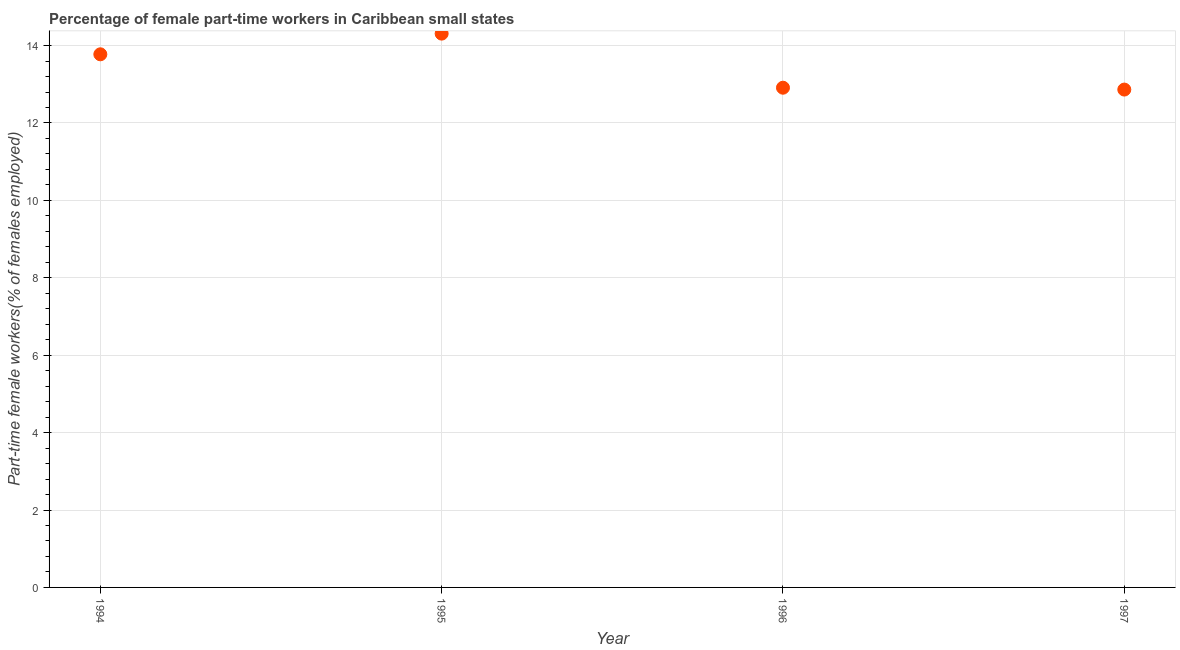What is the percentage of part-time female workers in 1996?
Ensure brevity in your answer.  12.91. Across all years, what is the maximum percentage of part-time female workers?
Give a very brief answer. 14.31. Across all years, what is the minimum percentage of part-time female workers?
Offer a very short reply. 12.86. In which year was the percentage of part-time female workers maximum?
Make the answer very short. 1995. What is the sum of the percentage of part-time female workers?
Your response must be concise. 53.86. What is the difference between the percentage of part-time female workers in 1994 and 1997?
Your answer should be very brief. 0.91. What is the average percentage of part-time female workers per year?
Provide a succinct answer. 13.46. What is the median percentage of part-time female workers?
Your answer should be compact. 13.34. In how many years, is the percentage of part-time female workers greater than 4 %?
Ensure brevity in your answer.  4. Do a majority of the years between 1995 and 1996 (inclusive) have percentage of part-time female workers greater than 8.8 %?
Offer a terse response. Yes. What is the ratio of the percentage of part-time female workers in 1995 to that in 1996?
Your answer should be very brief. 1.11. Is the difference between the percentage of part-time female workers in 1995 and 1996 greater than the difference between any two years?
Ensure brevity in your answer.  No. What is the difference between the highest and the second highest percentage of part-time female workers?
Your response must be concise. 0.53. What is the difference between the highest and the lowest percentage of part-time female workers?
Give a very brief answer. 1.45. Does the percentage of part-time female workers monotonically increase over the years?
Offer a terse response. No. How many years are there in the graph?
Offer a very short reply. 4. What is the difference between two consecutive major ticks on the Y-axis?
Make the answer very short. 2. Does the graph contain grids?
Provide a succinct answer. Yes. What is the title of the graph?
Ensure brevity in your answer.  Percentage of female part-time workers in Caribbean small states. What is the label or title of the Y-axis?
Your response must be concise. Part-time female workers(% of females employed). What is the Part-time female workers(% of females employed) in 1994?
Your answer should be compact. 13.77. What is the Part-time female workers(% of females employed) in 1995?
Your answer should be compact. 14.31. What is the Part-time female workers(% of females employed) in 1996?
Your answer should be compact. 12.91. What is the Part-time female workers(% of females employed) in 1997?
Make the answer very short. 12.86. What is the difference between the Part-time female workers(% of females employed) in 1994 and 1995?
Your answer should be very brief. -0.53. What is the difference between the Part-time female workers(% of females employed) in 1994 and 1996?
Make the answer very short. 0.86. What is the difference between the Part-time female workers(% of females employed) in 1994 and 1997?
Ensure brevity in your answer.  0.91. What is the difference between the Part-time female workers(% of females employed) in 1995 and 1996?
Give a very brief answer. 1.4. What is the difference between the Part-time female workers(% of females employed) in 1995 and 1997?
Your answer should be compact. 1.45. What is the difference between the Part-time female workers(% of females employed) in 1996 and 1997?
Your response must be concise. 0.05. What is the ratio of the Part-time female workers(% of females employed) in 1994 to that in 1996?
Your answer should be compact. 1.07. What is the ratio of the Part-time female workers(% of females employed) in 1994 to that in 1997?
Your answer should be compact. 1.07. What is the ratio of the Part-time female workers(% of females employed) in 1995 to that in 1996?
Your answer should be compact. 1.11. What is the ratio of the Part-time female workers(% of females employed) in 1995 to that in 1997?
Provide a succinct answer. 1.11. 